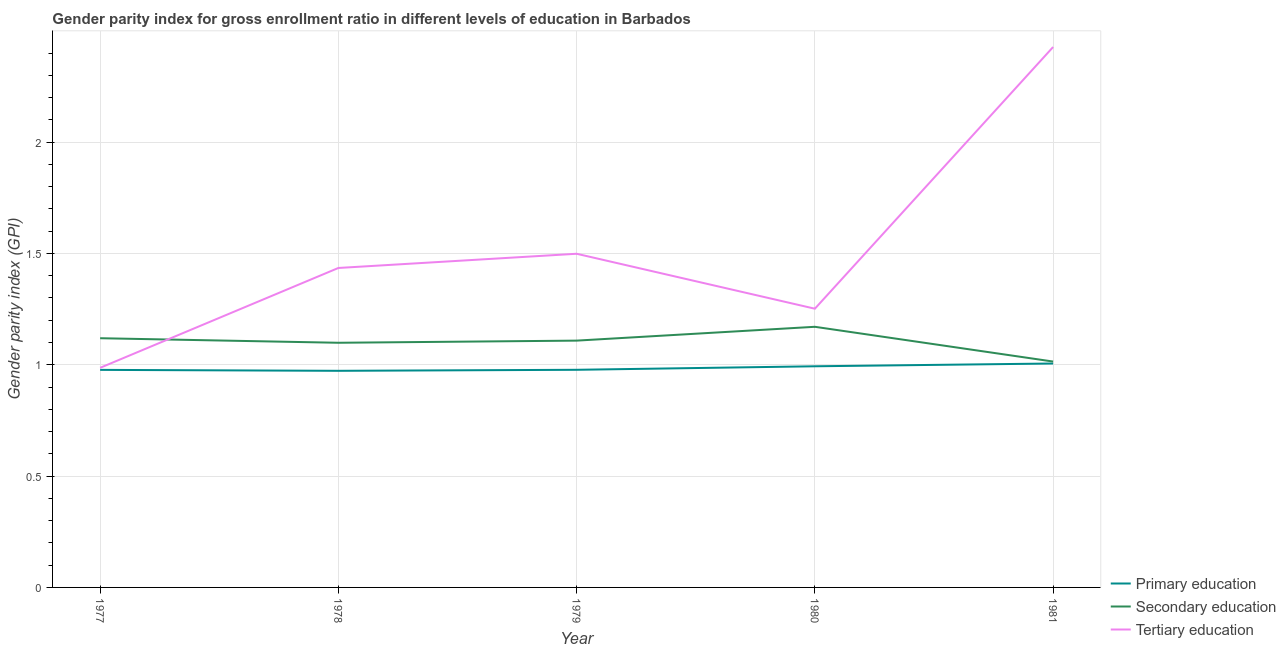How many different coloured lines are there?
Your answer should be very brief. 3. What is the gender parity index in secondary education in 1981?
Offer a terse response. 1.01. Across all years, what is the maximum gender parity index in tertiary education?
Provide a short and direct response. 2.43. Across all years, what is the minimum gender parity index in tertiary education?
Your answer should be compact. 0.99. In which year was the gender parity index in primary education minimum?
Your response must be concise. 1978. What is the total gender parity index in secondary education in the graph?
Give a very brief answer. 5.51. What is the difference between the gender parity index in secondary education in 1979 and that in 1980?
Your response must be concise. -0.06. What is the difference between the gender parity index in primary education in 1981 and the gender parity index in secondary education in 1978?
Make the answer very short. -0.09. What is the average gender parity index in secondary education per year?
Ensure brevity in your answer.  1.1. In the year 1981, what is the difference between the gender parity index in secondary education and gender parity index in tertiary education?
Ensure brevity in your answer.  -1.41. What is the ratio of the gender parity index in tertiary education in 1977 to that in 1978?
Offer a terse response. 0.69. What is the difference between the highest and the second highest gender parity index in secondary education?
Your answer should be very brief. 0.05. What is the difference between the highest and the lowest gender parity index in secondary education?
Provide a succinct answer. 0.16. In how many years, is the gender parity index in secondary education greater than the average gender parity index in secondary education taken over all years?
Your answer should be compact. 3. How many lines are there?
Provide a succinct answer. 3. Are the values on the major ticks of Y-axis written in scientific E-notation?
Provide a short and direct response. No. Does the graph contain grids?
Your answer should be compact. Yes. How many legend labels are there?
Your answer should be very brief. 3. What is the title of the graph?
Your answer should be very brief. Gender parity index for gross enrollment ratio in different levels of education in Barbados. What is the label or title of the Y-axis?
Provide a succinct answer. Gender parity index (GPI). What is the Gender parity index (GPI) in Primary education in 1977?
Keep it short and to the point. 0.98. What is the Gender parity index (GPI) of Secondary education in 1977?
Provide a succinct answer. 1.12. What is the Gender parity index (GPI) in Tertiary education in 1977?
Provide a short and direct response. 0.99. What is the Gender parity index (GPI) in Primary education in 1978?
Provide a succinct answer. 0.97. What is the Gender parity index (GPI) of Secondary education in 1978?
Provide a succinct answer. 1.1. What is the Gender parity index (GPI) of Tertiary education in 1978?
Make the answer very short. 1.43. What is the Gender parity index (GPI) of Primary education in 1979?
Your response must be concise. 0.98. What is the Gender parity index (GPI) of Secondary education in 1979?
Ensure brevity in your answer.  1.11. What is the Gender parity index (GPI) of Tertiary education in 1979?
Offer a very short reply. 1.5. What is the Gender parity index (GPI) of Secondary education in 1980?
Make the answer very short. 1.17. What is the Gender parity index (GPI) of Tertiary education in 1980?
Your response must be concise. 1.25. What is the Gender parity index (GPI) in Primary education in 1981?
Your response must be concise. 1.01. What is the Gender parity index (GPI) in Secondary education in 1981?
Your answer should be compact. 1.01. What is the Gender parity index (GPI) of Tertiary education in 1981?
Your answer should be very brief. 2.43. Across all years, what is the maximum Gender parity index (GPI) of Primary education?
Provide a succinct answer. 1.01. Across all years, what is the maximum Gender parity index (GPI) in Secondary education?
Keep it short and to the point. 1.17. Across all years, what is the maximum Gender parity index (GPI) of Tertiary education?
Keep it short and to the point. 2.43. Across all years, what is the minimum Gender parity index (GPI) in Primary education?
Make the answer very short. 0.97. Across all years, what is the minimum Gender parity index (GPI) in Secondary education?
Your response must be concise. 1.01. Across all years, what is the minimum Gender parity index (GPI) in Tertiary education?
Offer a terse response. 0.99. What is the total Gender parity index (GPI) of Primary education in the graph?
Offer a terse response. 4.93. What is the total Gender parity index (GPI) in Secondary education in the graph?
Provide a succinct answer. 5.51. What is the total Gender parity index (GPI) in Tertiary education in the graph?
Ensure brevity in your answer.  7.6. What is the difference between the Gender parity index (GPI) in Primary education in 1977 and that in 1978?
Make the answer very short. 0. What is the difference between the Gender parity index (GPI) of Secondary education in 1977 and that in 1978?
Give a very brief answer. 0.02. What is the difference between the Gender parity index (GPI) in Tertiary education in 1977 and that in 1978?
Provide a succinct answer. -0.45. What is the difference between the Gender parity index (GPI) of Primary education in 1977 and that in 1979?
Make the answer very short. -0. What is the difference between the Gender parity index (GPI) in Secondary education in 1977 and that in 1979?
Your answer should be compact. 0.01. What is the difference between the Gender parity index (GPI) in Tertiary education in 1977 and that in 1979?
Your answer should be compact. -0.51. What is the difference between the Gender parity index (GPI) in Primary education in 1977 and that in 1980?
Your response must be concise. -0.02. What is the difference between the Gender parity index (GPI) of Secondary education in 1977 and that in 1980?
Your answer should be compact. -0.05. What is the difference between the Gender parity index (GPI) in Tertiary education in 1977 and that in 1980?
Your answer should be compact. -0.27. What is the difference between the Gender parity index (GPI) of Primary education in 1977 and that in 1981?
Offer a terse response. -0.03. What is the difference between the Gender parity index (GPI) in Secondary education in 1977 and that in 1981?
Your response must be concise. 0.1. What is the difference between the Gender parity index (GPI) in Tertiary education in 1977 and that in 1981?
Ensure brevity in your answer.  -1.44. What is the difference between the Gender parity index (GPI) in Primary education in 1978 and that in 1979?
Provide a short and direct response. -0. What is the difference between the Gender parity index (GPI) in Secondary education in 1978 and that in 1979?
Provide a succinct answer. -0.01. What is the difference between the Gender parity index (GPI) of Tertiary education in 1978 and that in 1979?
Offer a very short reply. -0.06. What is the difference between the Gender parity index (GPI) of Primary education in 1978 and that in 1980?
Ensure brevity in your answer.  -0.02. What is the difference between the Gender parity index (GPI) in Secondary education in 1978 and that in 1980?
Ensure brevity in your answer.  -0.07. What is the difference between the Gender parity index (GPI) in Tertiary education in 1978 and that in 1980?
Make the answer very short. 0.18. What is the difference between the Gender parity index (GPI) in Primary education in 1978 and that in 1981?
Offer a very short reply. -0.03. What is the difference between the Gender parity index (GPI) of Secondary education in 1978 and that in 1981?
Your response must be concise. 0.08. What is the difference between the Gender parity index (GPI) in Tertiary education in 1978 and that in 1981?
Make the answer very short. -0.99. What is the difference between the Gender parity index (GPI) of Primary education in 1979 and that in 1980?
Your answer should be very brief. -0.02. What is the difference between the Gender parity index (GPI) of Secondary education in 1979 and that in 1980?
Ensure brevity in your answer.  -0.06. What is the difference between the Gender parity index (GPI) in Tertiary education in 1979 and that in 1980?
Provide a short and direct response. 0.25. What is the difference between the Gender parity index (GPI) in Primary education in 1979 and that in 1981?
Give a very brief answer. -0.03. What is the difference between the Gender parity index (GPI) in Secondary education in 1979 and that in 1981?
Offer a terse response. 0.09. What is the difference between the Gender parity index (GPI) of Tertiary education in 1979 and that in 1981?
Your response must be concise. -0.93. What is the difference between the Gender parity index (GPI) of Primary education in 1980 and that in 1981?
Give a very brief answer. -0.01. What is the difference between the Gender parity index (GPI) of Secondary education in 1980 and that in 1981?
Keep it short and to the point. 0.16. What is the difference between the Gender parity index (GPI) of Tertiary education in 1980 and that in 1981?
Keep it short and to the point. -1.18. What is the difference between the Gender parity index (GPI) of Primary education in 1977 and the Gender parity index (GPI) of Secondary education in 1978?
Ensure brevity in your answer.  -0.12. What is the difference between the Gender parity index (GPI) in Primary education in 1977 and the Gender parity index (GPI) in Tertiary education in 1978?
Give a very brief answer. -0.46. What is the difference between the Gender parity index (GPI) in Secondary education in 1977 and the Gender parity index (GPI) in Tertiary education in 1978?
Make the answer very short. -0.32. What is the difference between the Gender parity index (GPI) in Primary education in 1977 and the Gender parity index (GPI) in Secondary education in 1979?
Provide a succinct answer. -0.13. What is the difference between the Gender parity index (GPI) in Primary education in 1977 and the Gender parity index (GPI) in Tertiary education in 1979?
Ensure brevity in your answer.  -0.52. What is the difference between the Gender parity index (GPI) in Secondary education in 1977 and the Gender parity index (GPI) in Tertiary education in 1979?
Keep it short and to the point. -0.38. What is the difference between the Gender parity index (GPI) of Primary education in 1977 and the Gender parity index (GPI) of Secondary education in 1980?
Offer a very short reply. -0.19. What is the difference between the Gender parity index (GPI) of Primary education in 1977 and the Gender parity index (GPI) of Tertiary education in 1980?
Provide a succinct answer. -0.27. What is the difference between the Gender parity index (GPI) in Secondary education in 1977 and the Gender parity index (GPI) in Tertiary education in 1980?
Give a very brief answer. -0.13. What is the difference between the Gender parity index (GPI) in Primary education in 1977 and the Gender parity index (GPI) in Secondary education in 1981?
Ensure brevity in your answer.  -0.04. What is the difference between the Gender parity index (GPI) in Primary education in 1977 and the Gender parity index (GPI) in Tertiary education in 1981?
Your answer should be very brief. -1.45. What is the difference between the Gender parity index (GPI) of Secondary education in 1977 and the Gender parity index (GPI) of Tertiary education in 1981?
Provide a short and direct response. -1.31. What is the difference between the Gender parity index (GPI) of Primary education in 1978 and the Gender parity index (GPI) of Secondary education in 1979?
Offer a terse response. -0.14. What is the difference between the Gender parity index (GPI) in Primary education in 1978 and the Gender parity index (GPI) in Tertiary education in 1979?
Offer a terse response. -0.53. What is the difference between the Gender parity index (GPI) in Secondary education in 1978 and the Gender parity index (GPI) in Tertiary education in 1979?
Give a very brief answer. -0.4. What is the difference between the Gender parity index (GPI) in Primary education in 1978 and the Gender parity index (GPI) in Secondary education in 1980?
Your response must be concise. -0.2. What is the difference between the Gender parity index (GPI) of Primary education in 1978 and the Gender parity index (GPI) of Tertiary education in 1980?
Keep it short and to the point. -0.28. What is the difference between the Gender parity index (GPI) of Secondary education in 1978 and the Gender parity index (GPI) of Tertiary education in 1980?
Your response must be concise. -0.15. What is the difference between the Gender parity index (GPI) in Primary education in 1978 and the Gender parity index (GPI) in Secondary education in 1981?
Keep it short and to the point. -0.04. What is the difference between the Gender parity index (GPI) of Primary education in 1978 and the Gender parity index (GPI) of Tertiary education in 1981?
Offer a very short reply. -1.45. What is the difference between the Gender parity index (GPI) in Secondary education in 1978 and the Gender parity index (GPI) in Tertiary education in 1981?
Give a very brief answer. -1.33. What is the difference between the Gender parity index (GPI) in Primary education in 1979 and the Gender parity index (GPI) in Secondary education in 1980?
Ensure brevity in your answer.  -0.19. What is the difference between the Gender parity index (GPI) of Primary education in 1979 and the Gender parity index (GPI) of Tertiary education in 1980?
Provide a short and direct response. -0.27. What is the difference between the Gender parity index (GPI) of Secondary education in 1979 and the Gender parity index (GPI) of Tertiary education in 1980?
Keep it short and to the point. -0.14. What is the difference between the Gender parity index (GPI) of Primary education in 1979 and the Gender parity index (GPI) of Secondary education in 1981?
Keep it short and to the point. -0.04. What is the difference between the Gender parity index (GPI) of Primary education in 1979 and the Gender parity index (GPI) of Tertiary education in 1981?
Keep it short and to the point. -1.45. What is the difference between the Gender parity index (GPI) of Secondary education in 1979 and the Gender parity index (GPI) of Tertiary education in 1981?
Provide a short and direct response. -1.32. What is the difference between the Gender parity index (GPI) of Primary education in 1980 and the Gender parity index (GPI) of Secondary education in 1981?
Make the answer very short. -0.02. What is the difference between the Gender parity index (GPI) of Primary education in 1980 and the Gender parity index (GPI) of Tertiary education in 1981?
Offer a very short reply. -1.43. What is the difference between the Gender parity index (GPI) in Secondary education in 1980 and the Gender parity index (GPI) in Tertiary education in 1981?
Make the answer very short. -1.26. What is the average Gender parity index (GPI) of Primary education per year?
Give a very brief answer. 0.99. What is the average Gender parity index (GPI) in Secondary education per year?
Provide a short and direct response. 1.1. What is the average Gender parity index (GPI) of Tertiary education per year?
Offer a very short reply. 1.52. In the year 1977, what is the difference between the Gender parity index (GPI) of Primary education and Gender parity index (GPI) of Secondary education?
Keep it short and to the point. -0.14. In the year 1977, what is the difference between the Gender parity index (GPI) in Primary education and Gender parity index (GPI) in Tertiary education?
Your response must be concise. -0.01. In the year 1977, what is the difference between the Gender parity index (GPI) of Secondary education and Gender parity index (GPI) of Tertiary education?
Offer a very short reply. 0.13. In the year 1978, what is the difference between the Gender parity index (GPI) in Primary education and Gender parity index (GPI) in Secondary education?
Your answer should be compact. -0.13. In the year 1978, what is the difference between the Gender parity index (GPI) in Primary education and Gender parity index (GPI) in Tertiary education?
Give a very brief answer. -0.46. In the year 1978, what is the difference between the Gender parity index (GPI) of Secondary education and Gender parity index (GPI) of Tertiary education?
Your answer should be compact. -0.34. In the year 1979, what is the difference between the Gender parity index (GPI) in Primary education and Gender parity index (GPI) in Secondary education?
Keep it short and to the point. -0.13. In the year 1979, what is the difference between the Gender parity index (GPI) of Primary education and Gender parity index (GPI) of Tertiary education?
Your response must be concise. -0.52. In the year 1979, what is the difference between the Gender parity index (GPI) in Secondary education and Gender parity index (GPI) in Tertiary education?
Keep it short and to the point. -0.39. In the year 1980, what is the difference between the Gender parity index (GPI) of Primary education and Gender parity index (GPI) of Secondary education?
Your response must be concise. -0.18. In the year 1980, what is the difference between the Gender parity index (GPI) in Primary education and Gender parity index (GPI) in Tertiary education?
Provide a short and direct response. -0.26. In the year 1980, what is the difference between the Gender parity index (GPI) of Secondary education and Gender parity index (GPI) of Tertiary education?
Provide a succinct answer. -0.08. In the year 1981, what is the difference between the Gender parity index (GPI) of Primary education and Gender parity index (GPI) of Secondary education?
Give a very brief answer. -0.01. In the year 1981, what is the difference between the Gender parity index (GPI) of Primary education and Gender parity index (GPI) of Tertiary education?
Make the answer very short. -1.42. In the year 1981, what is the difference between the Gender parity index (GPI) in Secondary education and Gender parity index (GPI) in Tertiary education?
Ensure brevity in your answer.  -1.41. What is the ratio of the Gender parity index (GPI) in Secondary education in 1977 to that in 1978?
Provide a succinct answer. 1.02. What is the ratio of the Gender parity index (GPI) of Tertiary education in 1977 to that in 1978?
Give a very brief answer. 0.69. What is the ratio of the Gender parity index (GPI) in Secondary education in 1977 to that in 1979?
Give a very brief answer. 1.01. What is the ratio of the Gender parity index (GPI) of Tertiary education in 1977 to that in 1979?
Offer a terse response. 0.66. What is the ratio of the Gender parity index (GPI) in Primary education in 1977 to that in 1980?
Your response must be concise. 0.98. What is the ratio of the Gender parity index (GPI) in Secondary education in 1977 to that in 1980?
Your answer should be compact. 0.96. What is the ratio of the Gender parity index (GPI) in Tertiary education in 1977 to that in 1980?
Keep it short and to the point. 0.79. What is the ratio of the Gender parity index (GPI) in Primary education in 1977 to that in 1981?
Make the answer very short. 0.97. What is the ratio of the Gender parity index (GPI) in Secondary education in 1977 to that in 1981?
Your answer should be very brief. 1.1. What is the ratio of the Gender parity index (GPI) of Tertiary education in 1977 to that in 1981?
Your answer should be compact. 0.41. What is the ratio of the Gender parity index (GPI) in Tertiary education in 1978 to that in 1979?
Offer a terse response. 0.96. What is the ratio of the Gender parity index (GPI) in Primary education in 1978 to that in 1980?
Provide a succinct answer. 0.98. What is the ratio of the Gender parity index (GPI) in Secondary education in 1978 to that in 1980?
Provide a succinct answer. 0.94. What is the ratio of the Gender parity index (GPI) of Tertiary education in 1978 to that in 1980?
Your response must be concise. 1.15. What is the ratio of the Gender parity index (GPI) in Primary education in 1978 to that in 1981?
Your answer should be compact. 0.97. What is the ratio of the Gender parity index (GPI) of Secondary education in 1978 to that in 1981?
Your answer should be compact. 1.08. What is the ratio of the Gender parity index (GPI) in Tertiary education in 1978 to that in 1981?
Your answer should be very brief. 0.59. What is the ratio of the Gender parity index (GPI) of Primary education in 1979 to that in 1980?
Provide a succinct answer. 0.98. What is the ratio of the Gender parity index (GPI) in Secondary education in 1979 to that in 1980?
Your answer should be very brief. 0.95. What is the ratio of the Gender parity index (GPI) in Tertiary education in 1979 to that in 1980?
Ensure brevity in your answer.  1.2. What is the ratio of the Gender parity index (GPI) of Primary education in 1979 to that in 1981?
Your response must be concise. 0.97. What is the ratio of the Gender parity index (GPI) in Secondary education in 1979 to that in 1981?
Give a very brief answer. 1.09. What is the ratio of the Gender parity index (GPI) in Tertiary education in 1979 to that in 1981?
Offer a very short reply. 0.62. What is the ratio of the Gender parity index (GPI) in Primary education in 1980 to that in 1981?
Make the answer very short. 0.99. What is the ratio of the Gender parity index (GPI) of Secondary education in 1980 to that in 1981?
Ensure brevity in your answer.  1.15. What is the ratio of the Gender parity index (GPI) in Tertiary education in 1980 to that in 1981?
Offer a very short reply. 0.52. What is the difference between the highest and the second highest Gender parity index (GPI) of Primary education?
Your answer should be very brief. 0.01. What is the difference between the highest and the second highest Gender parity index (GPI) of Secondary education?
Your answer should be very brief. 0.05. What is the difference between the highest and the second highest Gender parity index (GPI) in Tertiary education?
Offer a terse response. 0.93. What is the difference between the highest and the lowest Gender parity index (GPI) of Primary education?
Your answer should be very brief. 0.03. What is the difference between the highest and the lowest Gender parity index (GPI) of Secondary education?
Your answer should be compact. 0.16. What is the difference between the highest and the lowest Gender parity index (GPI) in Tertiary education?
Your answer should be compact. 1.44. 